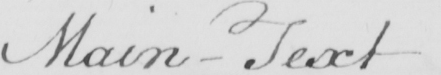Transcribe the text shown in this historical manuscript line. Main- Text 